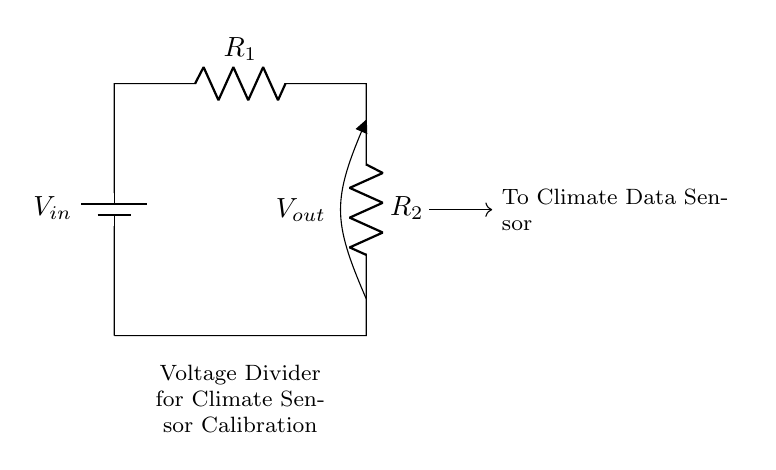What is the function of this circuit? The circuit serves as a voltage divider used for calibrating climate data sensors, which allows for a controlled output voltage based on the input.
Answer: Voltage divider for climate sensor calibration What component is used as the input source? The input source of this circuit is a battery, which provides the necessary voltage to power the circuit.
Answer: Battery What are the two resistors in this circuit? The two resistors in the circuit are labeled as R1 and R2, and they are positioned in series to create the voltage divider.
Answer: R1 and R2 What is the output voltage labeled as? The output voltage is labeled as Vout, which represents the voltage available to the climate data sensor based on the configuration of the resistors.
Answer: Vout What is the relationship between input voltage and output voltage in a voltage divider? In a voltage divider, the output voltage is determined by the ratio of the resistors and is proportional to the input voltage; specifically, Vout equals Vin times R2 divided by the total resistance R1 plus R2.
Answer: Vout equals Vin times R2 divided by (R1 plus R2) What will happen if R1 is much larger than R2? If R1 is much larger than R2, the output voltage Vout will be much lower than Vin, indicating that most of the input voltage is dropped across R1.
Answer: Vout is much lower than Vin What does the arrow pointing to the climate data sensor indicate? The arrow indicates that the output voltage Vout is directed to the climate data sensor, meaning it serves as the input voltage for that sensor.
Answer: Output voltage to climate data sensor 